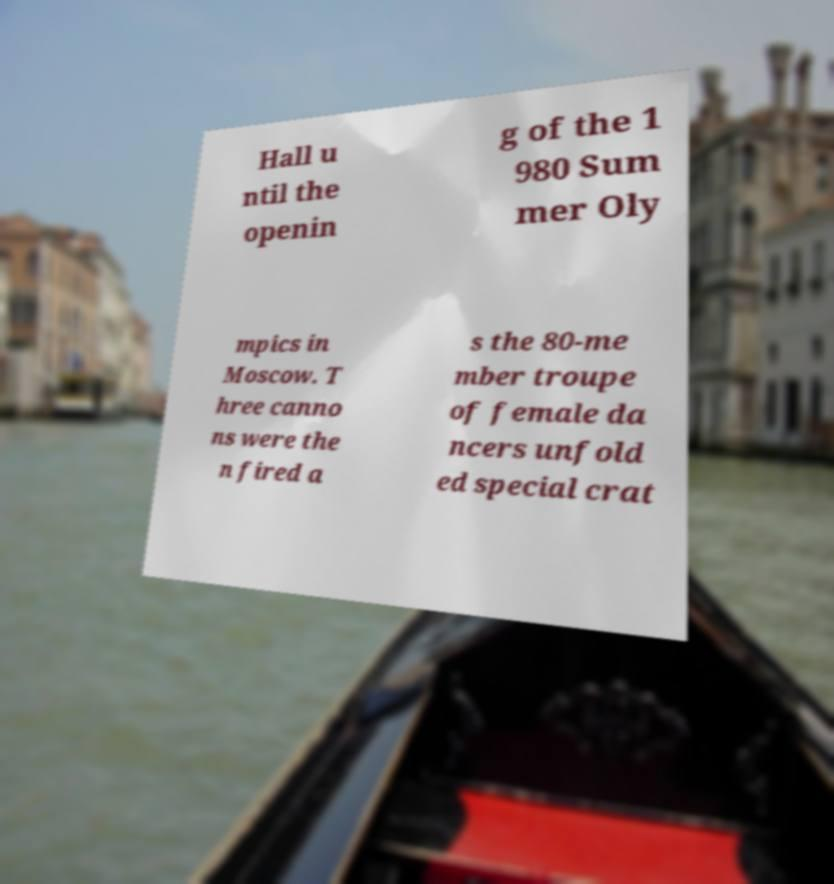Could you assist in decoding the text presented in this image and type it out clearly? Hall u ntil the openin g of the 1 980 Sum mer Oly mpics in Moscow. T hree canno ns were the n fired a s the 80-me mber troupe of female da ncers unfold ed special crat 